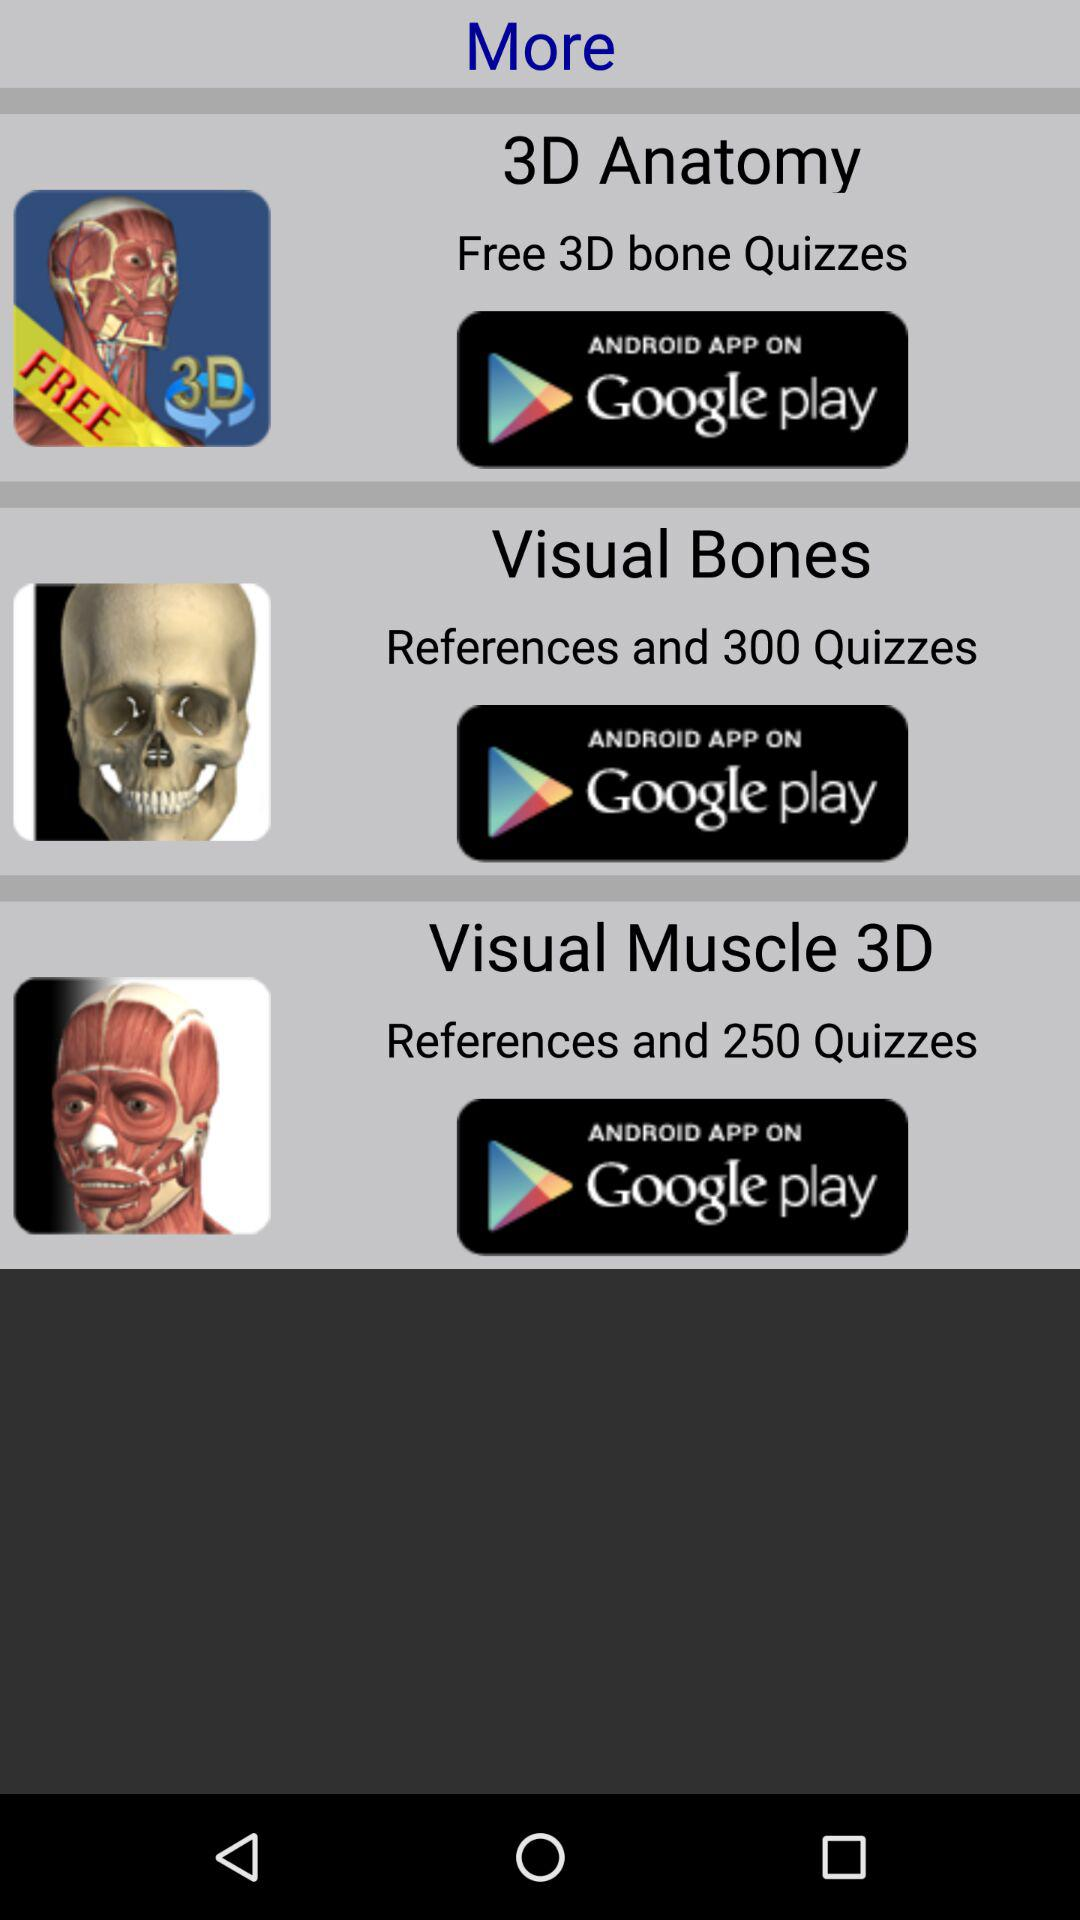What is the number of quizzes in "Visual Muscle 3D"? The number of quizzes in "Visual Muscle 3D" is 250. 